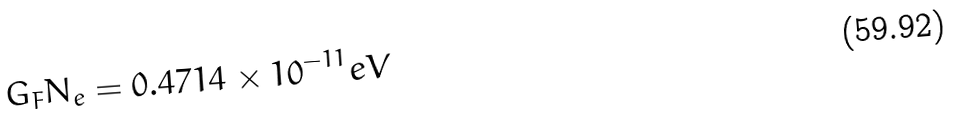Convert formula to latex. <formula><loc_0><loc_0><loc_500><loc_500>G _ { F } N _ { e } = 0 . 4 7 1 4 \times 1 0 ^ { - 1 1 } e V</formula> 